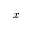Convert formula to latex. <formula><loc_0><loc_0><loc_500><loc_500>x</formula> 